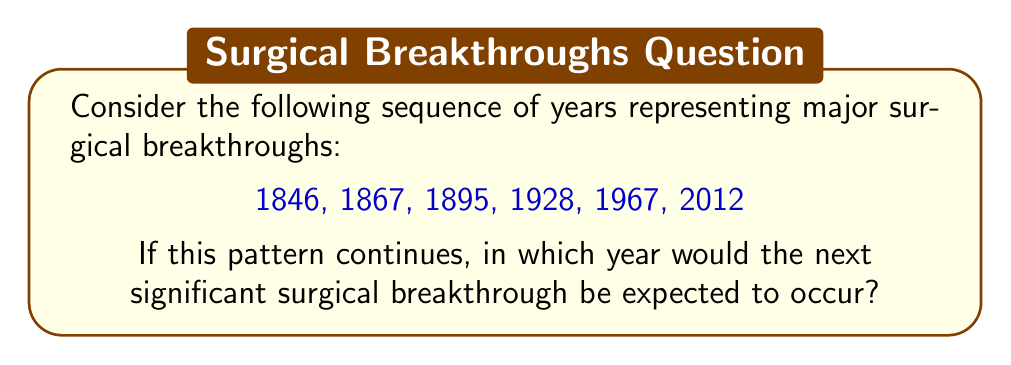Provide a solution to this math problem. To solve this problem, we need to analyze the pattern in the given sequence of years:

1. Calculate the differences between consecutive years:
   1867 - 1846 = 21
   1895 - 1867 = 28
   1928 - 1895 = 33
   1967 - 1928 = 39
   2012 - 1967 = 45

2. Observe the pattern in these differences:
   21, 28, 33, 39, 45

3. Calculate the differences between these differences:
   28 - 21 = 7
   33 - 28 = 5
   39 - 33 = 6
   45 - 39 = 6

4. We can see that the second-order differences are approximately constant, with an average of 6.

5. Assuming this pattern continues, the next difference in the original sequence would be:
   45 + 6 = 51

6. Therefore, the next year in the sequence would be:
   2012 + 51 = 2063

Thus, if this pattern continues, the next significant surgical breakthrough would be expected to occur in 2063.
Answer: 2063 